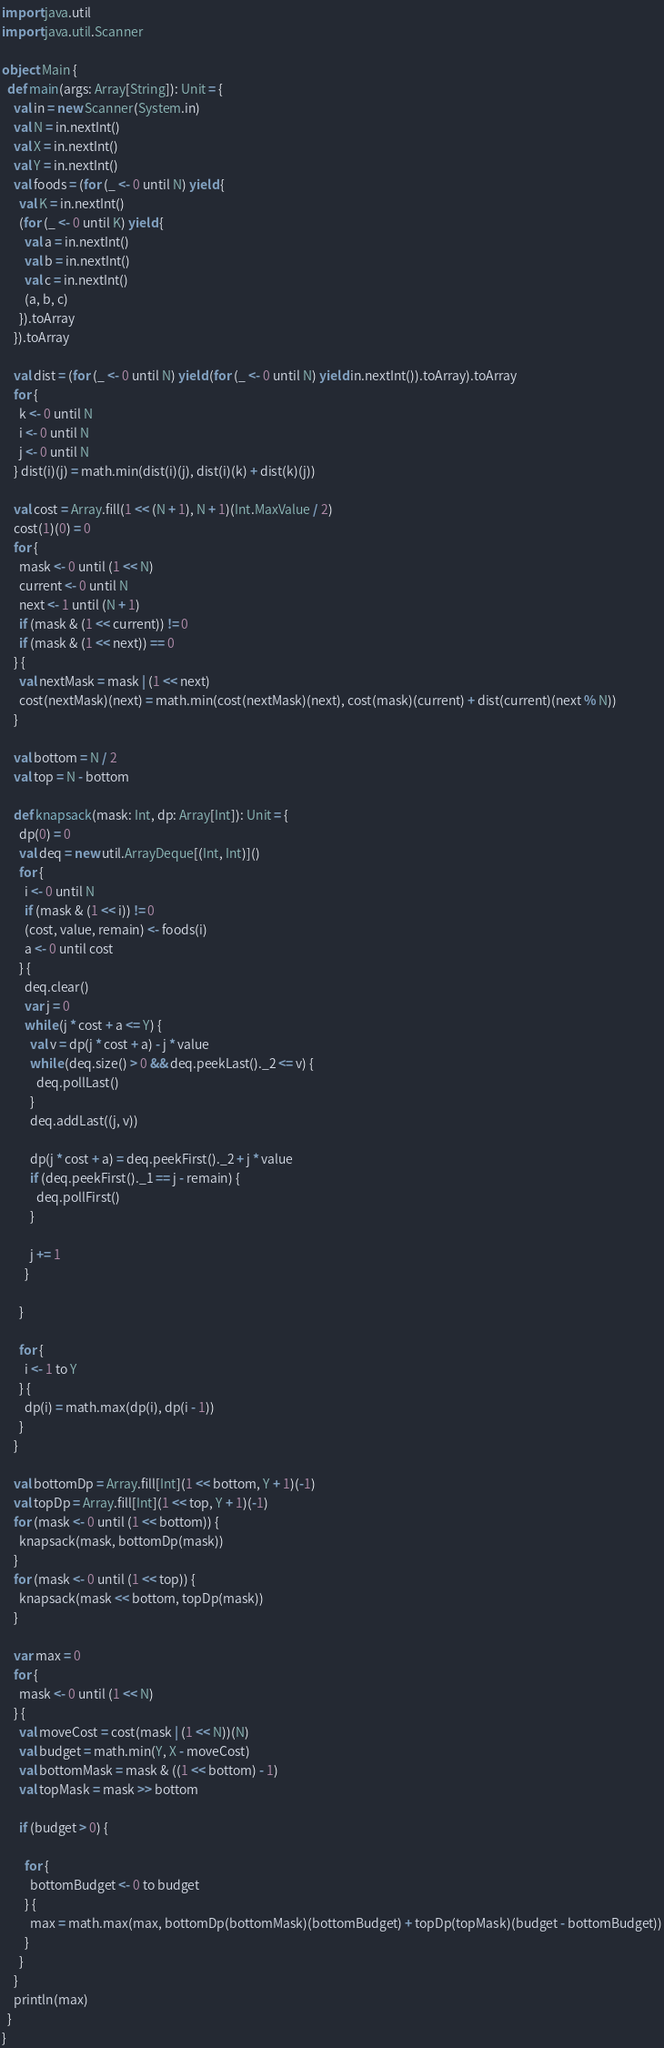<code> <loc_0><loc_0><loc_500><loc_500><_Scala_>import java.util
import java.util.Scanner

object Main {
  def main(args: Array[String]): Unit = {
    val in = new Scanner(System.in)
    val N = in.nextInt()
    val X = in.nextInt()
    val Y = in.nextInt()
    val foods = (for (_ <- 0 until N) yield {
      val K = in.nextInt()
      (for (_ <- 0 until K) yield {
        val a = in.nextInt()
        val b = in.nextInt()
        val c = in.nextInt()
        (a, b, c)
      }).toArray
    }).toArray

    val dist = (for (_ <- 0 until N) yield (for (_ <- 0 until N) yield in.nextInt()).toArray).toArray
    for {
      k <- 0 until N
      i <- 0 until N
      j <- 0 until N
    } dist(i)(j) = math.min(dist(i)(j), dist(i)(k) + dist(k)(j))

    val cost = Array.fill(1 << (N + 1), N + 1)(Int.MaxValue / 2)
    cost(1)(0) = 0
    for {
      mask <- 0 until (1 << N)
      current <- 0 until N
      next <- 1 until (N + 1)
      if (mask & (1 << current)) != 0
      if (mask & (1 << next)) == 0
    } {
      val nextMask = mask | (1 << next)
      cost(nextMask)(next) = math.min(cost(nextMask)(next), cost(mask)(current) + dist(current)(next % N))
    }

    val bottom = N / 2
    val top = N - bottom

    def knapsack(mask: Int, dp: Array[Int]): Unit = {
      dp(0) = 0
      val deq = new util.ArrayDeque[(Int, Int)]()
      for {
        i <- 0 until N
        if (mask & (1 << i)) != 0
        (cost, value, remain) <- foods(i)
        a <- 0 until cost
      } {
        deq.clear()
        var j = 0
        while (j * cost + a <= Y) {
          val v = dp(j * cost + a) - j * value
          while (deq.size() > 0 && deq.peekLast()._2 <= v) {
            deq.pollLast()
          }
          deq.addLast((j, v))

          dp(j * cost + a) = deq.peekFirst()._2 + j * value
          if (deq.peekFirst()._1 == j - remain) {
            deq.pollFirst()
          }

          j += 1
        }

      }

      for {
        i <- 1 to Y
      } {
        dp(i) = math.max(dp(i), dp(i - 1))
      }
    }

    val bottomDp = Array.fill[Int](1 << bottom, Y + 1)(-1)
    val topDp = Array.fill[Int](1 << top, Y + 1)(-1)
    for (mask <- 0 until (1 << bottom)) {
      knapsack(mask, bottomDp(mask))
    }
    for (mask <- 0 until (1 << top)) {
      knapsack(mask << bottom, topDp(mask))
    }

    var max = 0
    for {
      mask <- 0 until (1 << N)
    } {
      val moveCost = cost(mask | (1 << N))(N)
      val budget = math.min(Y, X - moveCost)
      val bottomMask = mask & ((1 << bottom) - 1)
      val topMask = mask >> bottom

      if (budget > 0) {

        for {
          bottomBudget <- 0 to budget
        } {
          max = math.max(max, bottomDp(bottomMask)(bottomBudget) + topDp(topMask)(budget - bottomBudget))
        }
      }
    }
    println(max)
  }
}</code> 